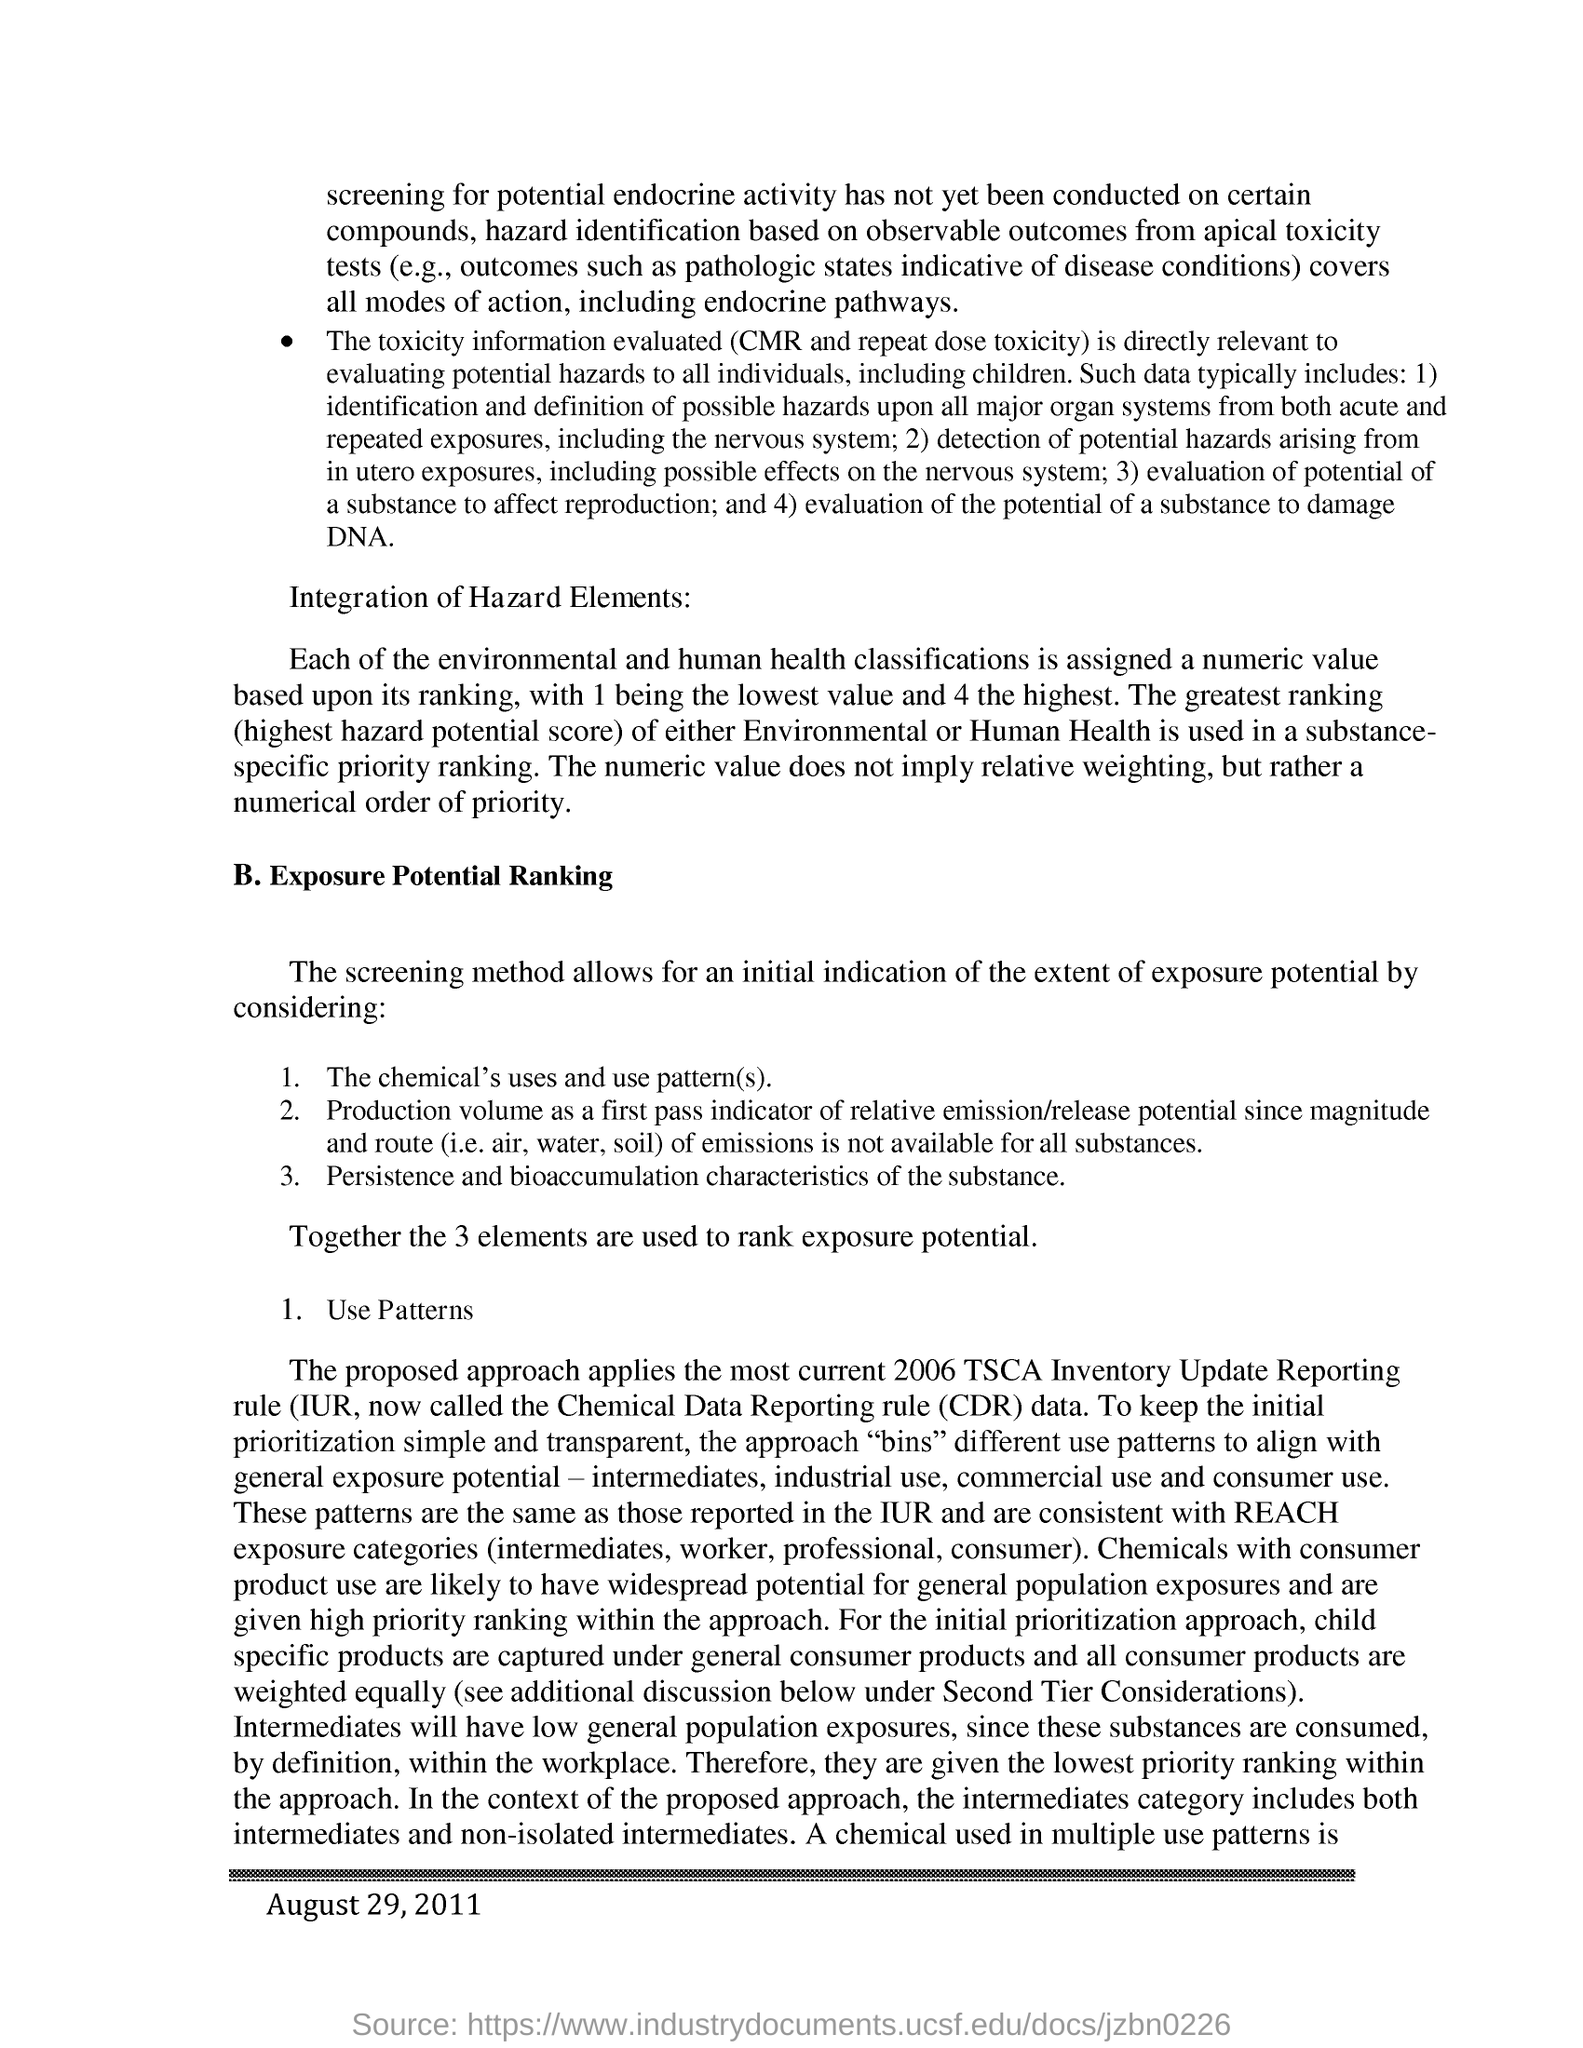What is the date mentioned in the bottom?
Ensure brevity in your answer.  August 29, 2011. What is the heading of the point B?
Your answer should be very brief. Exposure Potential Ranking. Together how many elements are used to make rank exposure potential?
Make the answer very short. 3 elements. The proposed approach applies the most to which year's TSCA Inventory Update Reporting rule?
Offer a terse response. 2006. 